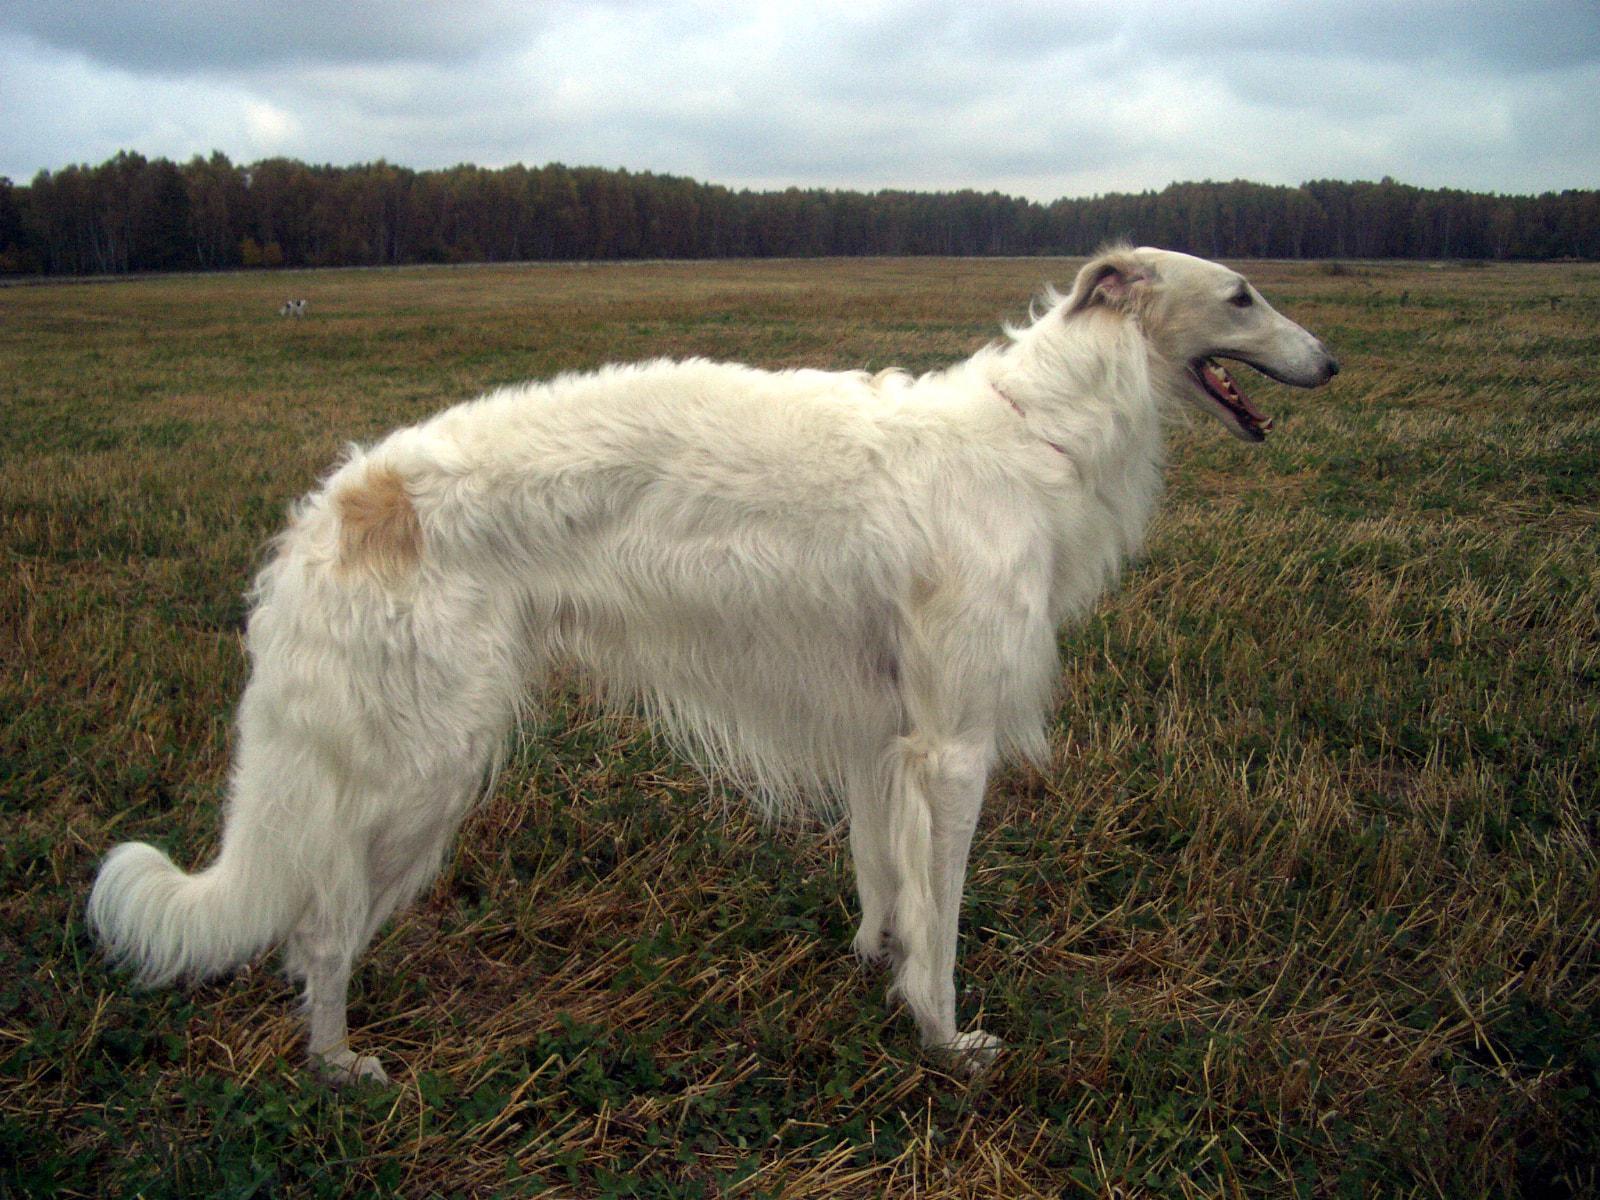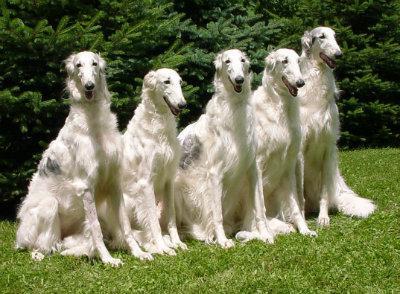The first image is the image on the left, the second image is the image on the right. For the images displayed, is the sentence "Each image shows one hound standing instead of walking." factually correct? Answer yes or no. No. The first image is the image on the left, the second image is the image on the right. For the images displayed, is the sentence "One dog is with a handler and one is not." factually correct? Answer yes or no. No. 